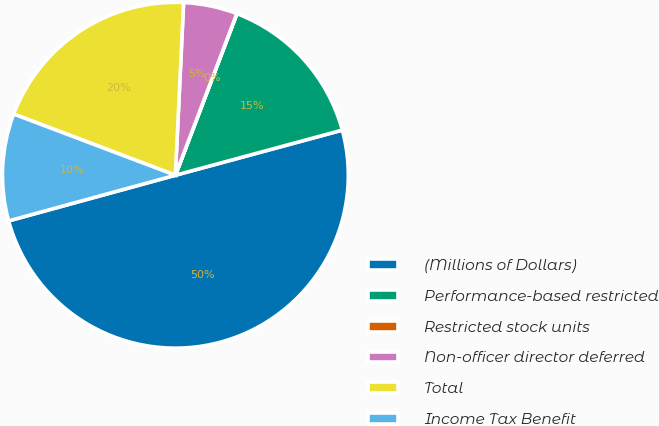Convert chart to OTSL. <chart><loc_0><loc_0><loc_500><loc_500><pie_chart><fcel>(Millions of Dollars)<fcel>Performance-based restricted<fcel>Restricted stock units<fcel>Non-officer director deferred<fcel>Total<fcel>Income Tax Benefit<nl><fcel>49.95%<fcel>15.0%<fcel>0.02%<fcel>5.02%<fcel>20.0%<fcel>10.01%<nl></chart> 